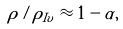Convert formula to latex. <formula><loc_0><loc_0><loc_500><loc_500>\rho / \rho _ { I v } \approx 1 - \alpha ,</formula> 